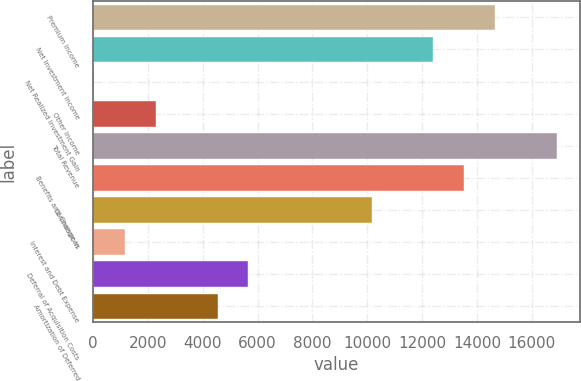Convert chart. <chart><loc_0><loc_0><loc_500><loc_500><bar_chart><fcel>Premium Income<fcel>Net Investment Income<fcel>Net Realized Investment Gain<fcel>Other Income<fcel>Total Revenue<fcel>Benefits and Change in<fcel>Commissions<fcel>Interest and Debt Expense<fcel>Deferral of Acquisition Costs<fcel>Amortization of Deferred<nl><fcel>14660.8<fcel>12411.5<fcel>40.3<fcel>2289.6<fcel>16910<fcel>13536.1<fcel>10162.1<fcel>1164.95<fcel>5663.55<fcel>4538.9<nl></chart> 